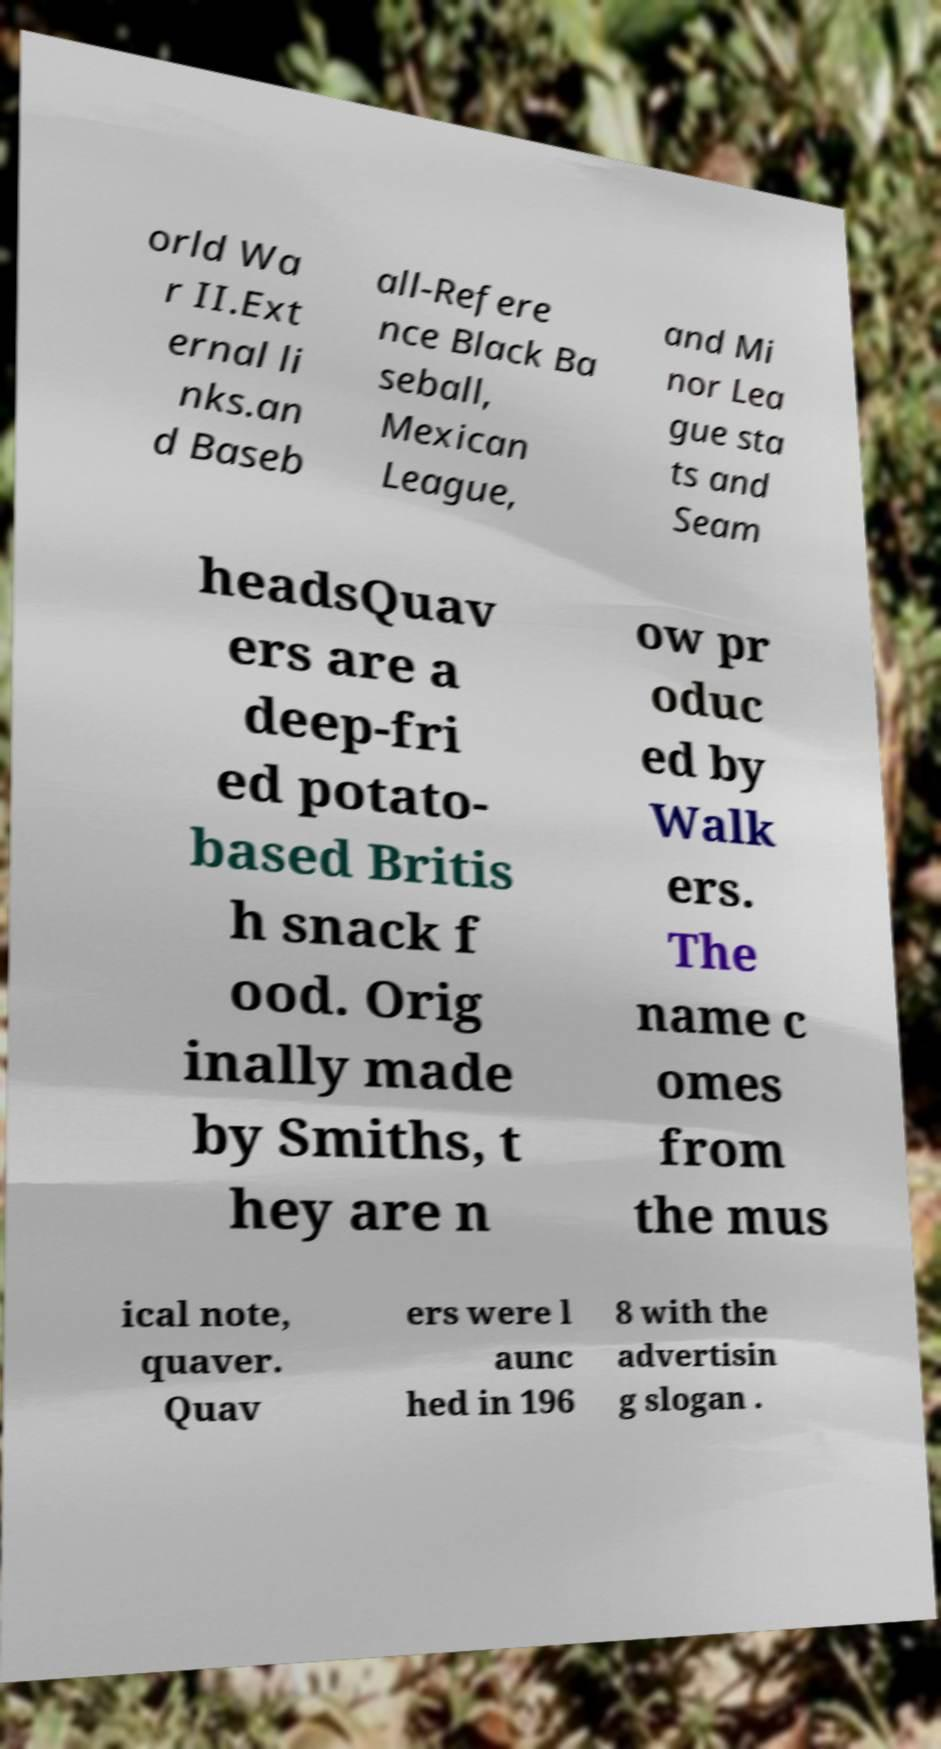Please identify and transcribe the text found in this image. orld Wa r II.Ext ernal li nks.an d Baseb all-Refere nce Black Ba seball, Mexican League, and Mi nor Lea gue sta ts and Seam headsQuav ers are a deep-fri ed potato- based Britis h snack f ood. Orig inally made by Smiths, t hey are n ow pr oduc ed by Walk ers. The name c omes from the mus ical note, quaver. Quav ers were l aunc hed in 196 8 with the advertisin g slogan . 